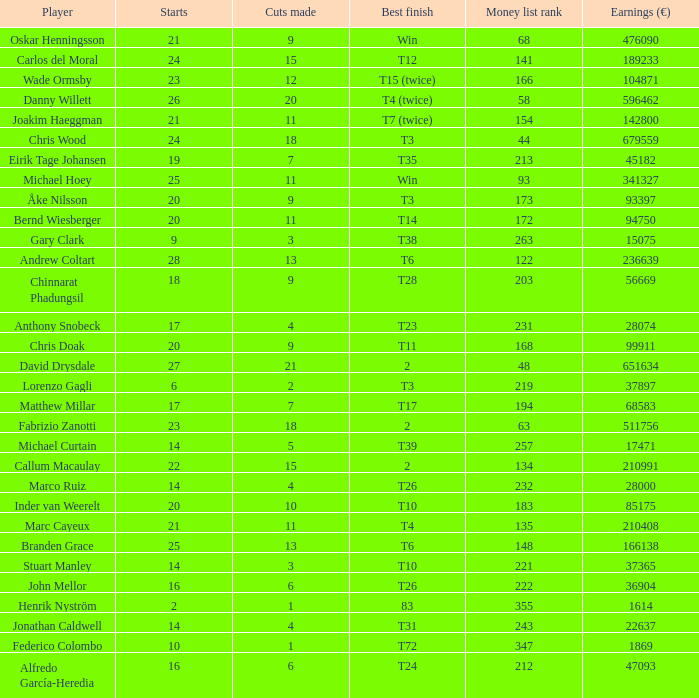How many incisions did gary clark produce? 3.0. 